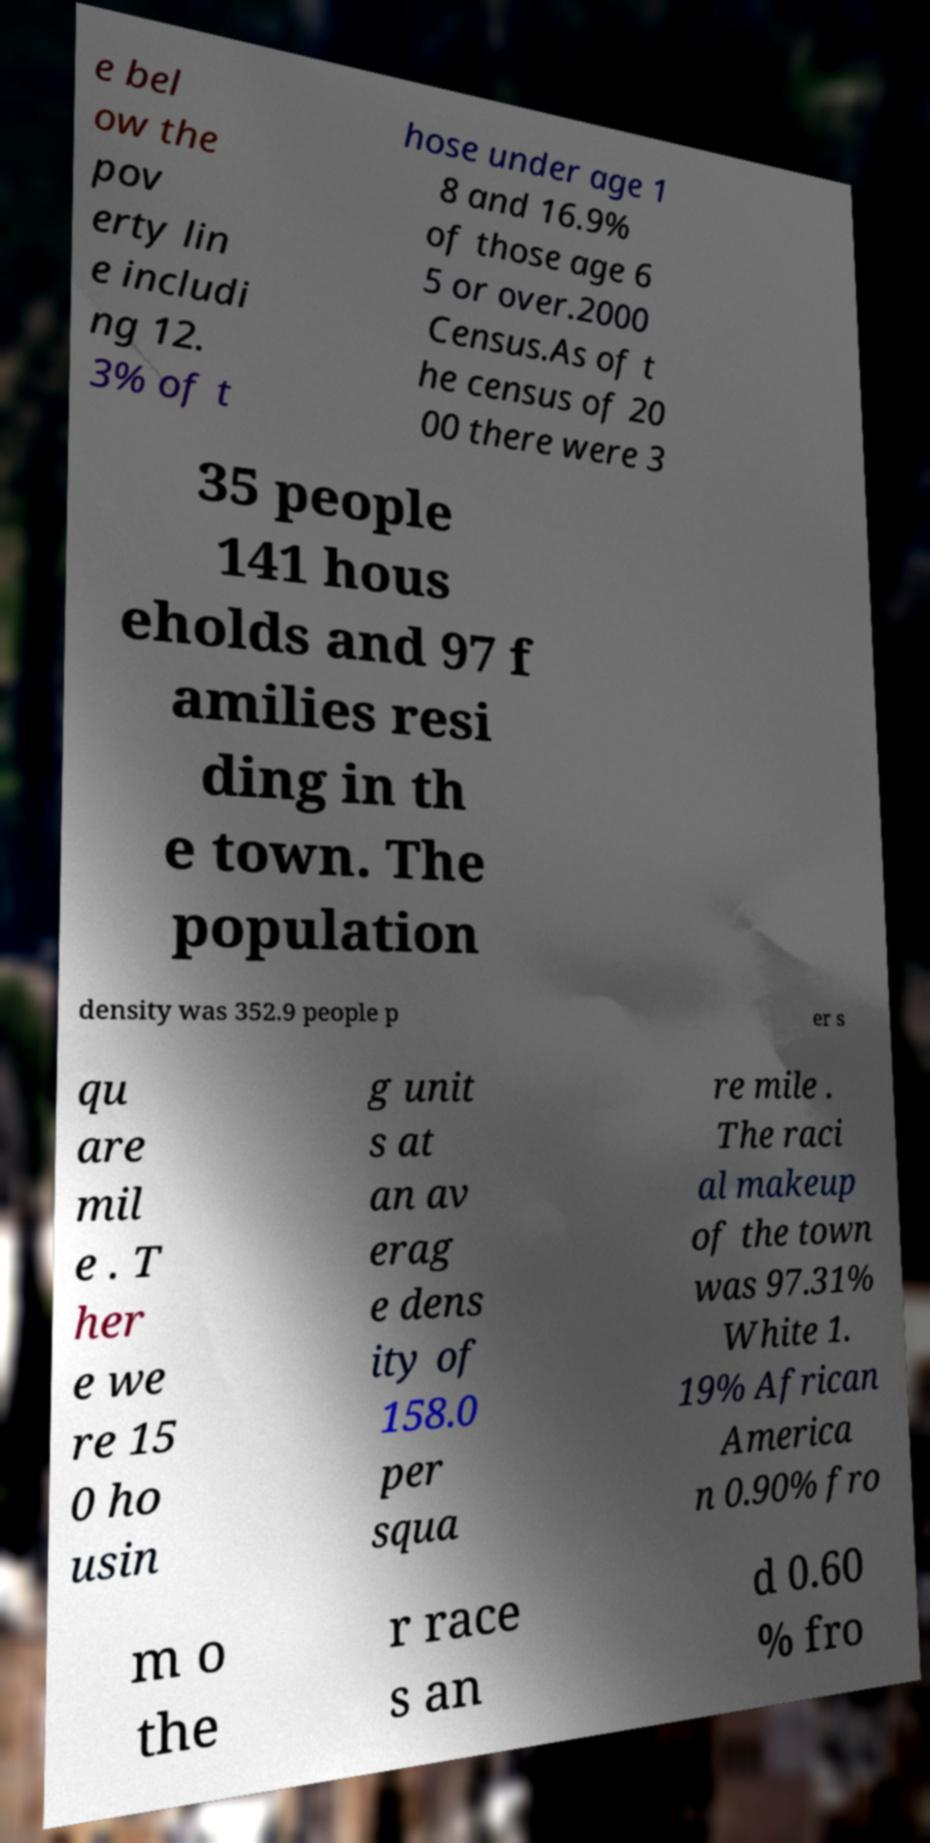Can you accurately transcribe the text from the provided image for me? e bel ow the pov erty lin e includi ng 12. 3% of t hose under age 1 8 and 16.9% of those age 6 5 or over.2000 Census.As of t he census of 20 00 there were 3 35 people 141 hous eholds and 97 f amilies resi ding in th e town. The population density was 352.9 people p er s qu are mil e . T her e we re 15 0 ho usin g unit s at an av erag e dens ity of 158.0 per squa re mile . The raci al makeup of the town was 97.31% White 1. 19% African America n 0.90% fro m o the r race s an d 0.60 % fro 